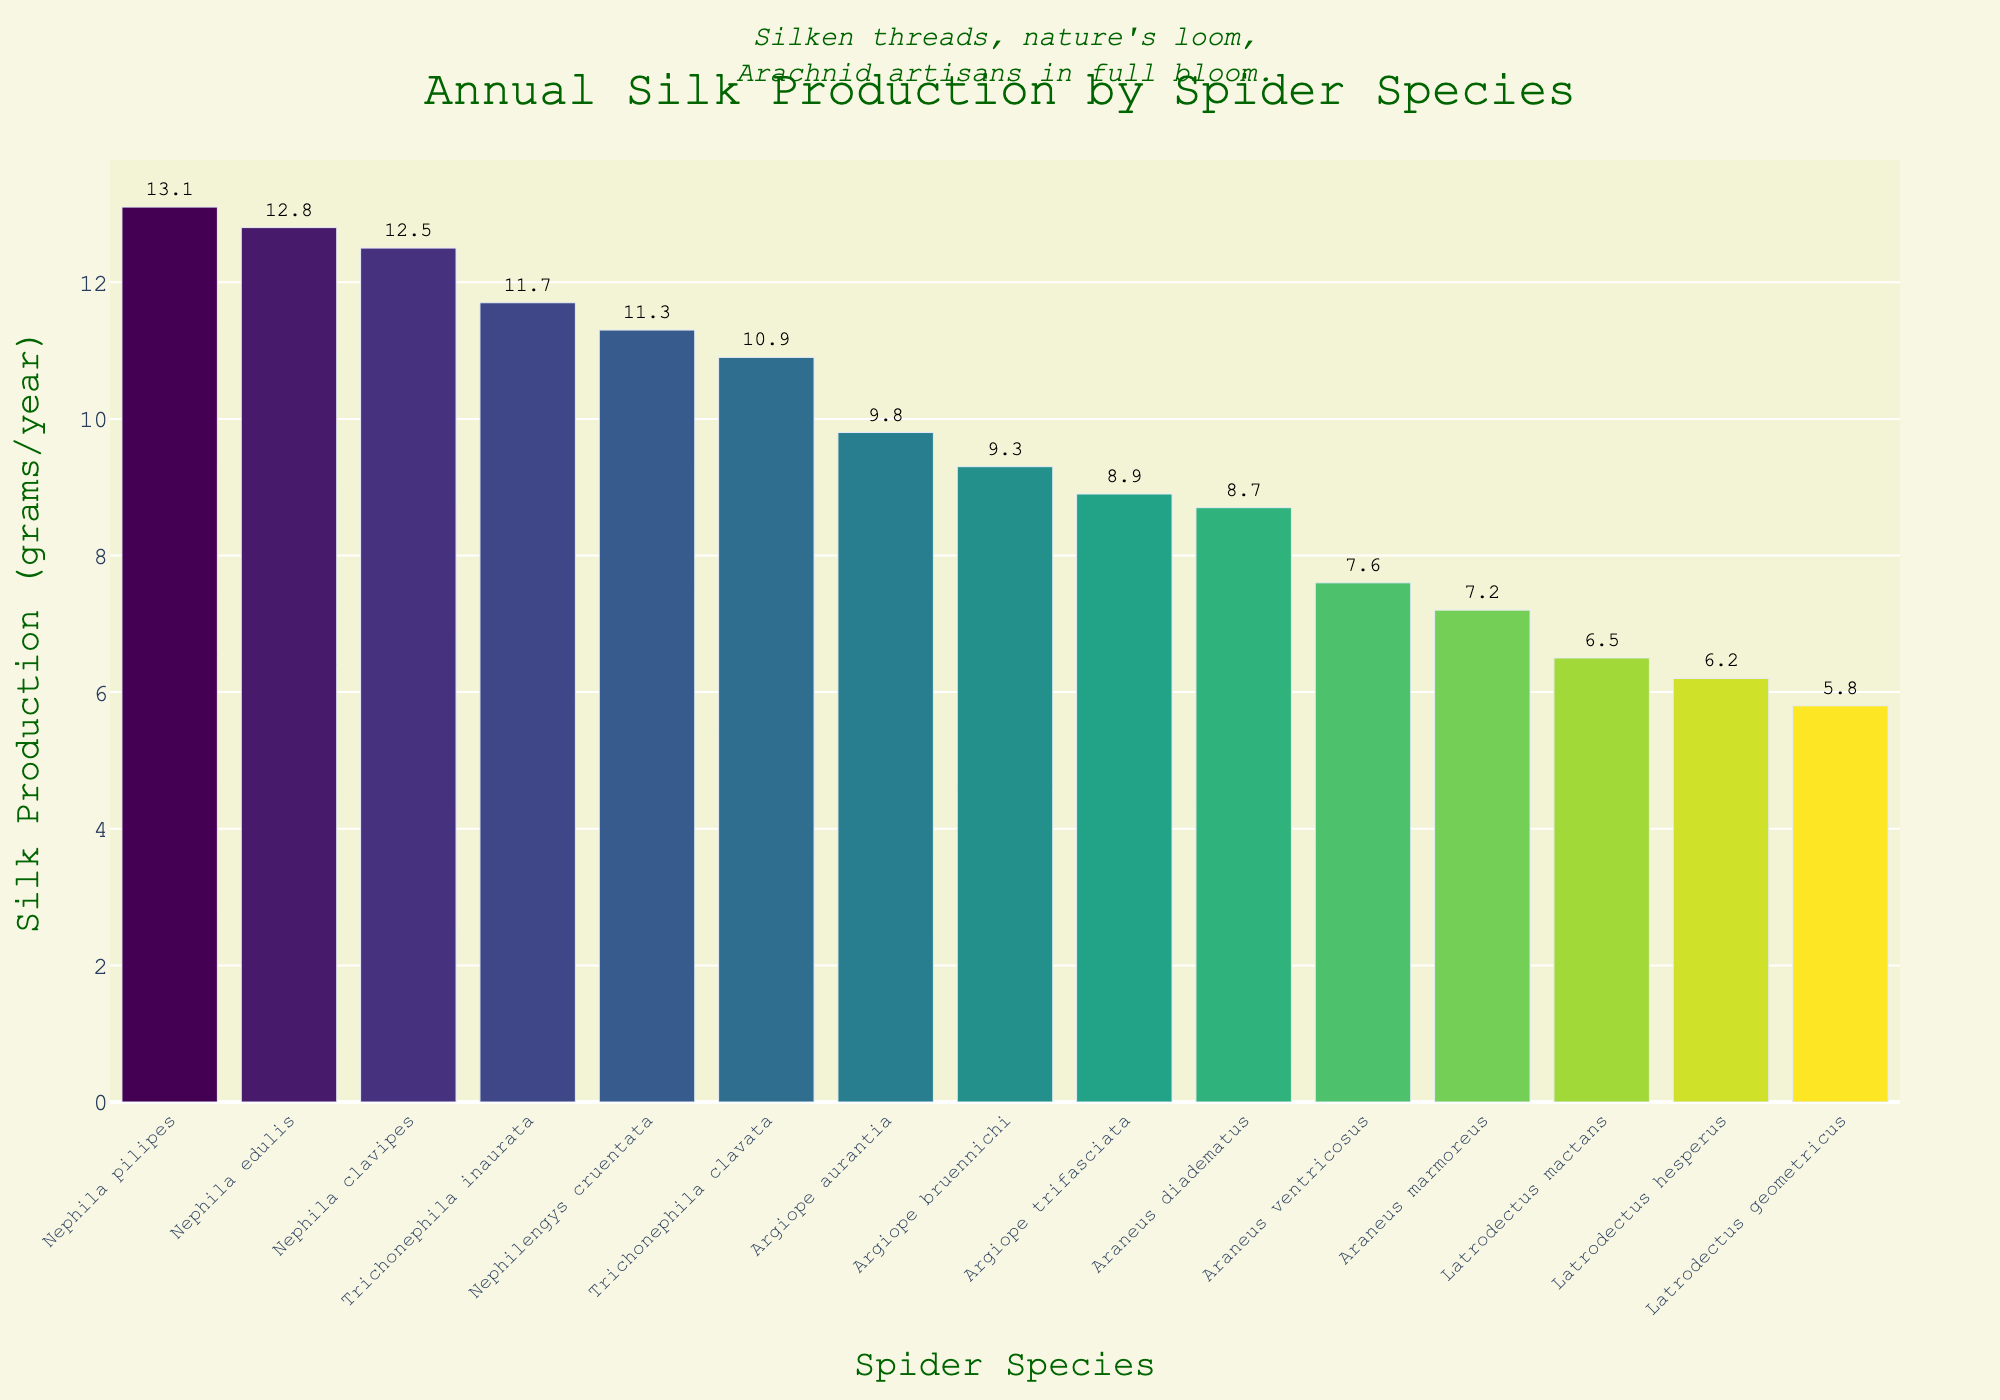Which spider species produces the most silk annually? The bar representing Nephila pilipes is the tallest in the chart, indicating the highest annual silk production.
Answer: Nephila pilipes How much more silk does Nephila pilipes produce compared to Latrodectus geometricus? Nephila pilipes produces 13.1 grams of silk annually, while Latrodectus geometricus produces 5.8 grams. The difference is 13.1 - 5.8.
Answer: 7.3 grams Which spider species is right in the middle of the sorted list in terms of silk production? The data sorted in descending order has 15 species, so the middle one is 8th in the list. Checking the 8th position in the sorted data, it's Araneus ventricosus.
Answer: Araneus ventricosus Compare the silk production of Argiope aurantia and Argiope trifasciata. Do they produce equal amounts of silk per year? Argiope aurantia produces 9.8 grams annually, and Argiope trifasciata produces 8.9 grams. These values are not equal.
Answer: No What is the total silk production for the three species with the lowest production? The three species with the lowest production are Latrodectus geometricus (5.8), Latrodectus hesperus (6.2), and Latrodectus mactans (6.5). The total is 5.8 + 6.2 + 6.5.
Answer: 18.5 grams On average, how much silk does the Latrodectus genus produce annually? The Latrodectus species are Latrodectus hesperus, Latrodectus geometricus, and Latrodectus mactans, with values 6.2, 5.8, and 6.5 grams respectively. The average is (6.2 + 5.8 + 6.5)/3.
Answer: 6.17 grams Which species has the closest silk production to the average silk production of all species? Calculate the total and the average silk production first. The total is 12.5 + 8.7 + 6.2 + 9.8 + 11.3 + 10.9 + 7.6 + 13.1 + 8.9 + 5.8 + 12.8 + 7.2 + 11.7 + 9.3 + 6.5 = 142.3 grams. The average is 142.3/15 ≈ 9.49 grams. The closest value is Argiope aurantia with 9.8 grams.
Answer: Argiope aurantia Which genus, Nephila or Argiope, produces more silk on average? Nephila species (N. clavipes: 12.5, N. cruentata: 11.3, N. pilipes: 13.1, N. edulis: 12.8), average = (12.5+11.3+13.1+12.8)/4 = 12.43 grams. Argiope species (A. aurantia: 9.8, A. trifasciata: 8.9, A. bruennichi: 9.3), average = (9.8+8.9+9.3)/3 = 9.33 grams. Nephila has a higher average.
Answer: Nephila What is the difference in silk production between Araneus diadematus and Araneus marmoreus? Araneus diadematus produces 8.7 grams, and Araneus marmoreus produces 7.2 grams. The difference is 8.7 - 7.2.
Answer: 1.5 grams How many species produce silk more than the average production of Latrodectus genus? The average production of Latrodectus genus is 6.17 grams. Counting the species producing more than 6.17 grams (Nephila clavipes, Araneus diadematus, Argiope aurantia, Nephilengys cruentata, Trichonephila clavata, Araneus ventricosus, Nephila pilipes, Argiope trifasciata, Nephila edulis, Araneus marmoreus, Trichonephila inaurata, Argiope bruennichi) gives us 12 species.
Answer: 12 species 